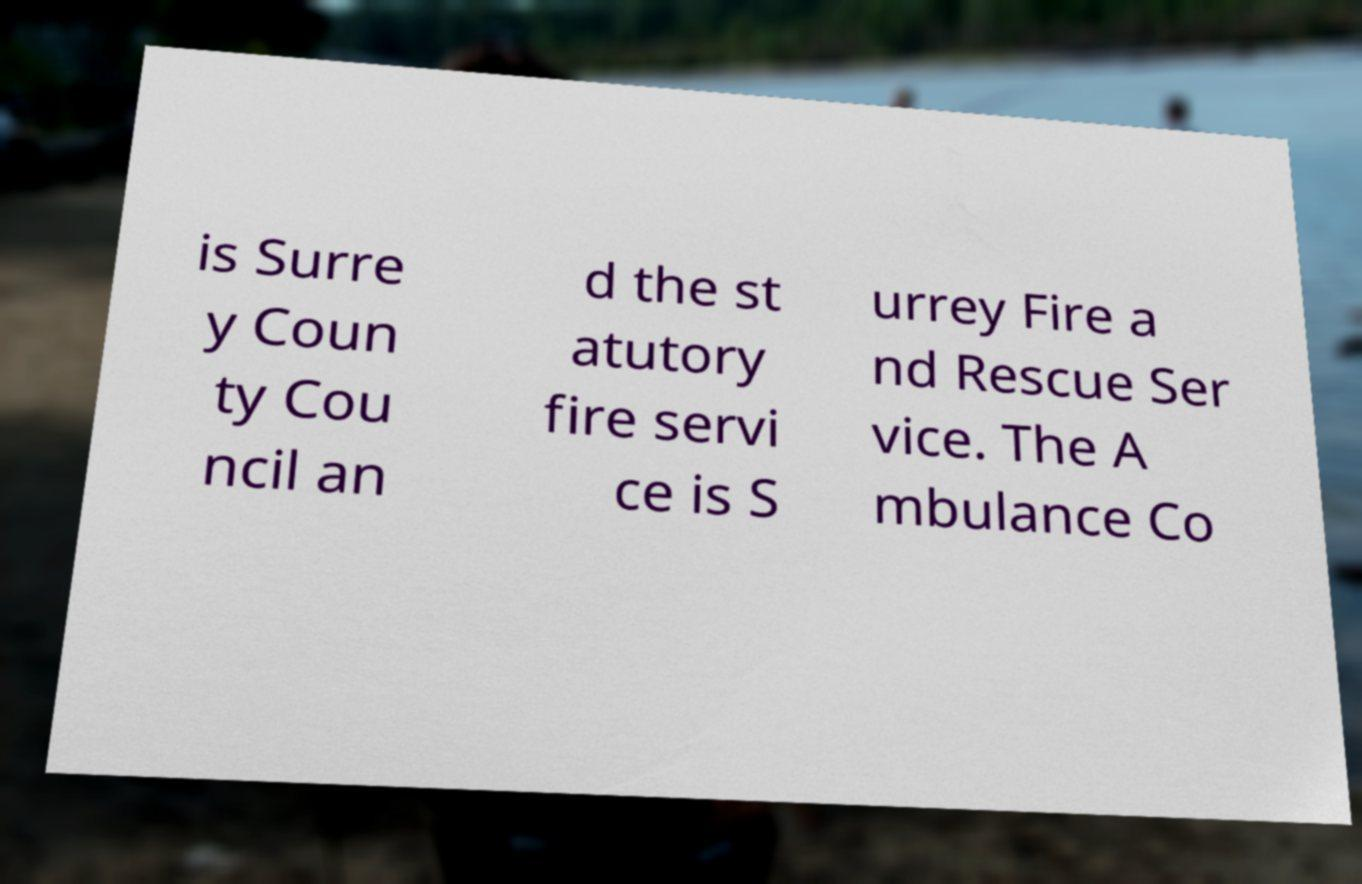Please identify and transcribe the text found in this image. is Surre y Coun ty Cou ncil an d the st atutory fire servi ce is S urrey Fire a nd Rescue Ser vice. The A mbulance Co 